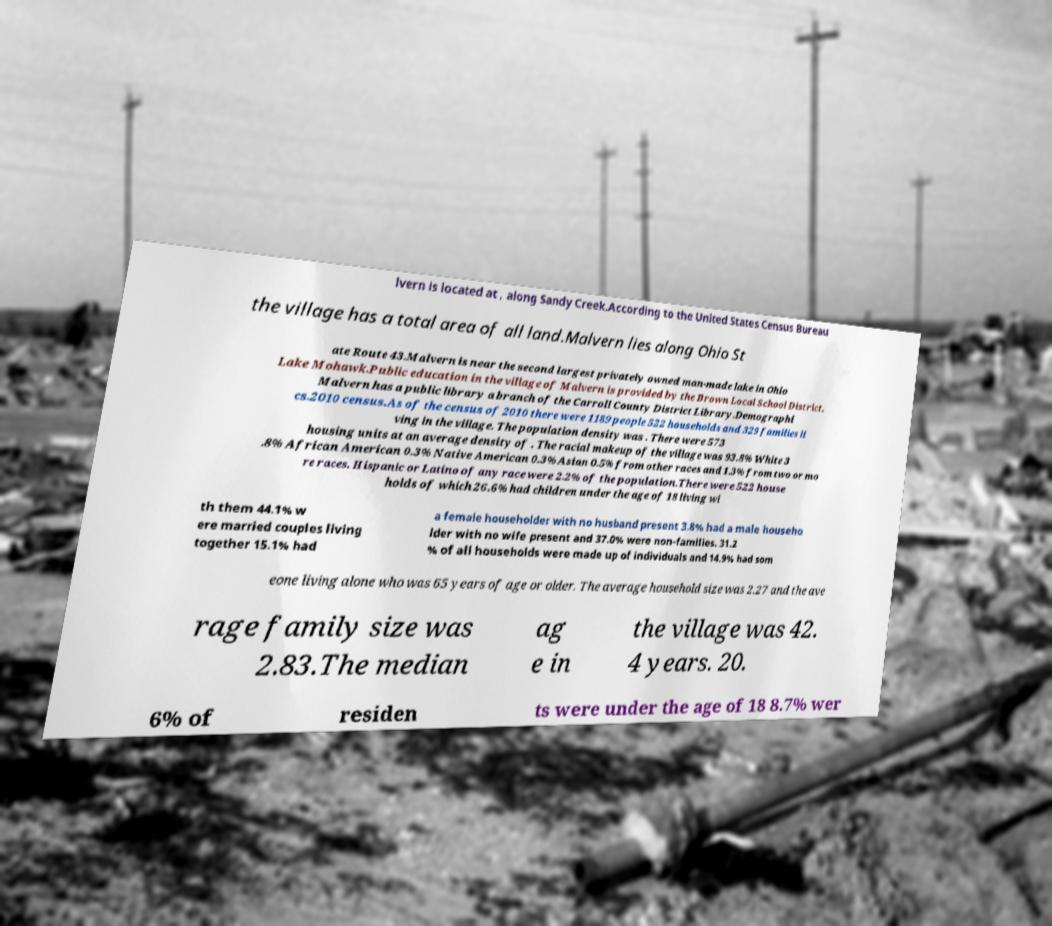What messages or text are displayed in this image? I need them in a readable, typed format. lvern is located at , along Sandy Creek.According to the United States Census Bureau the village has a total area of all land.Malvern lies along Ohio St ate Route 43.Malvern is near the second largest privately owned man-made lake in Ohio Lake Mohawk.Public education in the village of Malvern is provided by the Brown Local School District. Malvern has a public library a branch of the Carroll County District Library.Demographi cs.2010 census.As of the census of 2010 there were 1189 people 522 households and 329 families li ving in the village. The population density was . There were 573 housing units at an average density of . The racial makeup of the village was 93.8% White 3 .8% African American 0.3% Native American 0.3% Asian 0.5% from other races and 1.3% from two or mo re races. Hispanic or Latino of any race were 2.2% of the population.There were 522 house holds of which 26.6% had children under the age of 18 living wi th them 44.1% w ere married couples living together 15.1% had a female householder with no husband present 3.8% had a male househo lder with no wife present and 37.0% were non-families. 31.2 % of all households were made up of individuals and 14.9% had som eone living alone who was 65 years of age or older. The average household size was 2.27 and the ave rage family size was 2.83.The median ag e in the village was 42. 4 years. 20. 6% of residen ts were under the age of 18 8.7% wer 